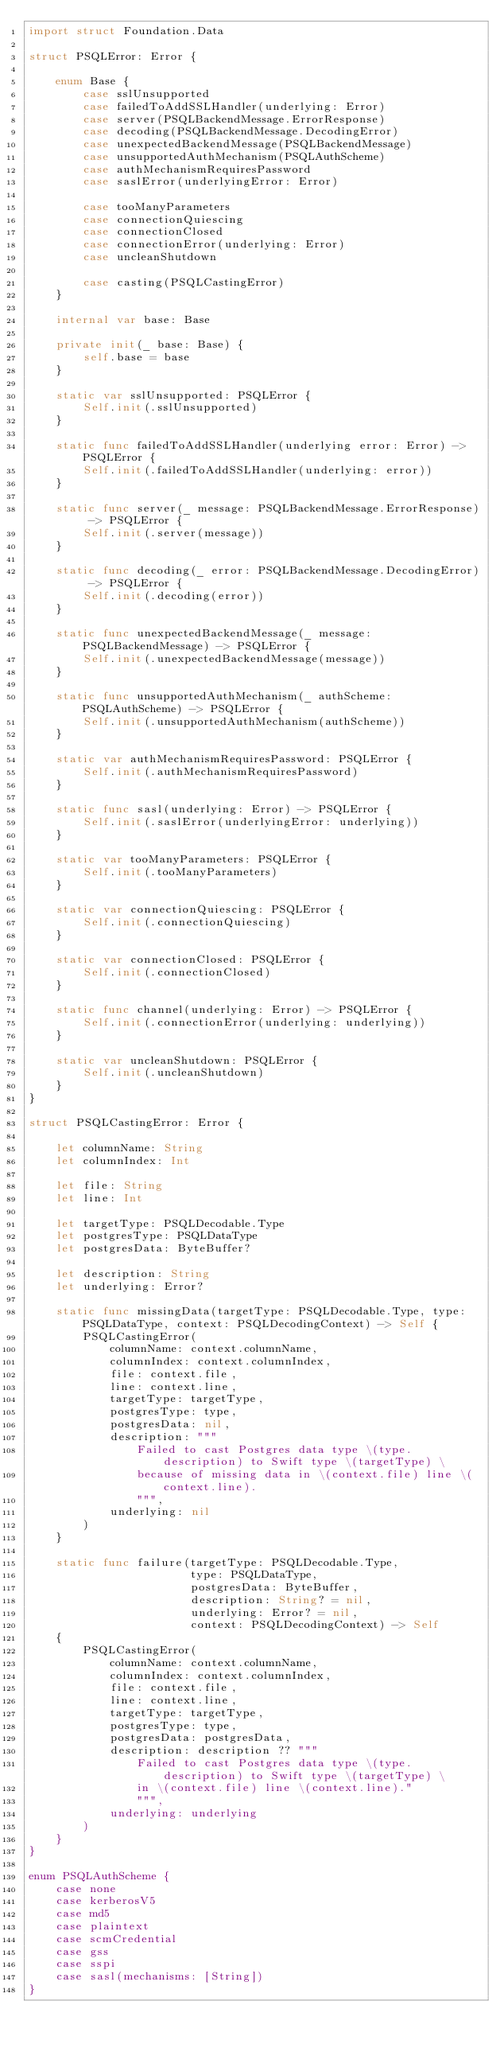Convert code to text. <code><loc_0><loc_0><loc_500><loc_500><_Swift_>import struct Foundation.Data

struct PSQLError: Error {
    
    enum Base {
        case sslUnsupported
        case failedToAddSSLHandler(underlying: Error)
        case server(PSQLBackendMessage.ErrorResponse)
        case decoding(PSQLBackendMessage.DecodingError)
        case unexpectedBackendMessage(PSQLBackendMessage)
        case unsupportedAuthMechanism(PSQLAuthScheme)
        case authMechanismRequiresPassword
        case saslError(underlyingError: Error)
        
        case tooManyParameters
        case connectionQuiescing
        case connectionClosed
        case connectionError(underlying: Error)
        case uncleanShutdown
        
        case casting(PSQLCastingError)
    }
    
    internal var base: Base
    
    private init(_ base: Base) {
        self.base = base
    }
    
    static var sslUnsupported: PSQLError {
        Self.init(.sslUnsupported)
    }
    
    static func failedToAddSSLHandler(underlying error: Error) -> PSQLError {
        Self.init(.failedToAddSSLHandler(underlying: error))
    }
    
    static func server(_ message: PSQLBackendMessage.ErrorResponse) -> PSQLError {
        Self.init(.server(message))
    }
    
    static func decoding(_ error: PSQLBackendMessage.DecodingError) -> PSQLError {
        Self.init(.decoding(error))
    }
    
    static func unexpectedBackendMessage(_ message: PSQLBackendMessage) -> PSQLError {
        Self.init(.unexpectedBackendMessage(message))
    }
    
    static func unsupportedAuthMechanism(_ authScheme: PSQLAuthScheme) -> PSQLError {
        Self.init(.unsupportedAuthMechanism(authScheme))
    }
    
    static var authMechanismRequiresPassword: PSQLError {
        Self.init(.authMechanismRequiresPassword)
    }
    
    static func sasl(underlying: Error) -> PSQLError {
        Self.init(.saslError(underlyingError: underlying))
    }
    
    static var tooManyParameters: PSQLError {
        Self.init(.tooManyParameters)
    }
    
    static var connectionQuiescing: PSQLError {
        Self.init(.connectionQuiescing)
    }
    
    static var connectionClosed: PSQLError {
        Self.init(.connectionClosed)
    }
    
    static func channel(underlying: Error) -> PSQLError {
        Self.init(.connectionError(underlying: underlying))
    }
    
    static var uncleanShutdown: PSQLError {
        Self.init(.uncleanShutdown)
    }
}

struct PSQLCastingError: Error {
    
    let columnName: String
    let columnIndex: Int
    
    let file: String
    let line: Int
    
    let targetType: PSQLDecodable.Type
    let postgresType: PSQLDataType
    let postgresData: ByteBuffer?
    
    let description: String
    let underlying: Error?
    
    static func missingData(targetType: PSQLDecodable.Type, type: PSQLDataType, context: PSQLDecodingContext) -> Self {
        PSQLCastingError(
            columnName: context.columnName,
            columnIndex: context.columnIndex,
            file: context.file,
            line: context.line,
            targetType: targetType,
            postgresType: type,
            postgresData: nil,
            description: """
                Failed to cast Postgres data type \(type.description) to Swift type \(targetType) \
                because of missing data in \(context.file) line \(context.line).
                """,
            underlying: nil
        )
    }
    
    static func failure(targetType: PSQLDecodable.Type,
                        type: PSQLDataType,
                        postgresData: ByteBuffer,
                        description: String? = nil,
                        underlying: Error? = nil,
                        context: PSQLDecodingContext) -> Self
    {
        PSQLCastingError(
            columnName: context.columnName,
            columnIndex: context.columnIndex,
            file: context.file,
            line: context.line,
            targetType: targetType,
            postgresType: type,
            postgresData: postgresData,
            description: description ?? """
                Failed to cast Postgres data type \(type.description) to Swift type \(targetType) \
                in \(context.file) line \(context.line)."
                """,
            underlying: underlying
        )
    }
}

enum PSQLAuthScheme {
    case none
    case kerberosV5
    case md5
    case plaintext
    case scmCredential
    case gss
    case sspi
    case sasl(mechanisms: [String])
}
</code> 